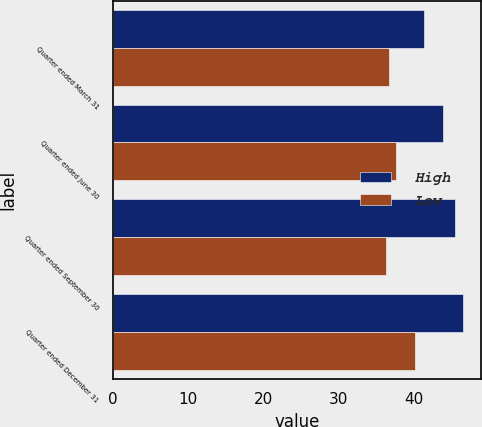Convert chart to OTSL. <chart><loc_0><loc_0><loc_500><loc_500><stacked_bar_chart><ecel><fcel>Quarter ended March 31<fcel>Quarter ended June 30<fcel>Quarter ended September 30<fcel>Quarter ended December 31<nl><fcel>High<fcel>41.31<fcel>43.84<fcel>45.45<fcel>46.53<nl><fcel>Low<fcel>36.63<fcel>37.64<fcel>36.34<fcel>40.08<nl></chart> 